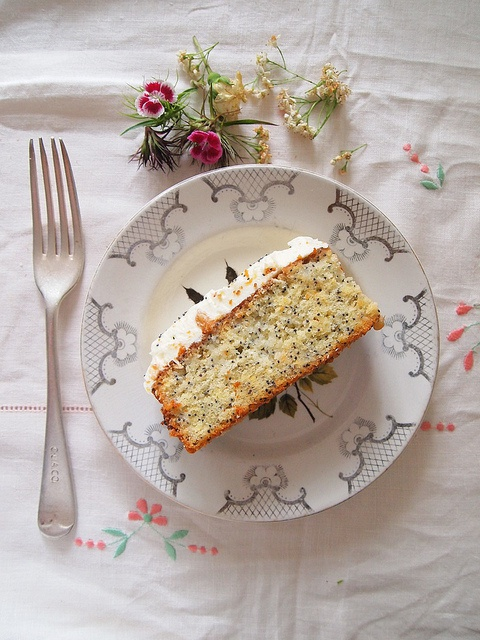Describe the objects in this image and their specific colors. I can see dining table in darkgray, lightgray, and gray tones, cake in darkgray, tan, and ivory tones, and fork in darkgray, lightgray, and gray tones in this image. 